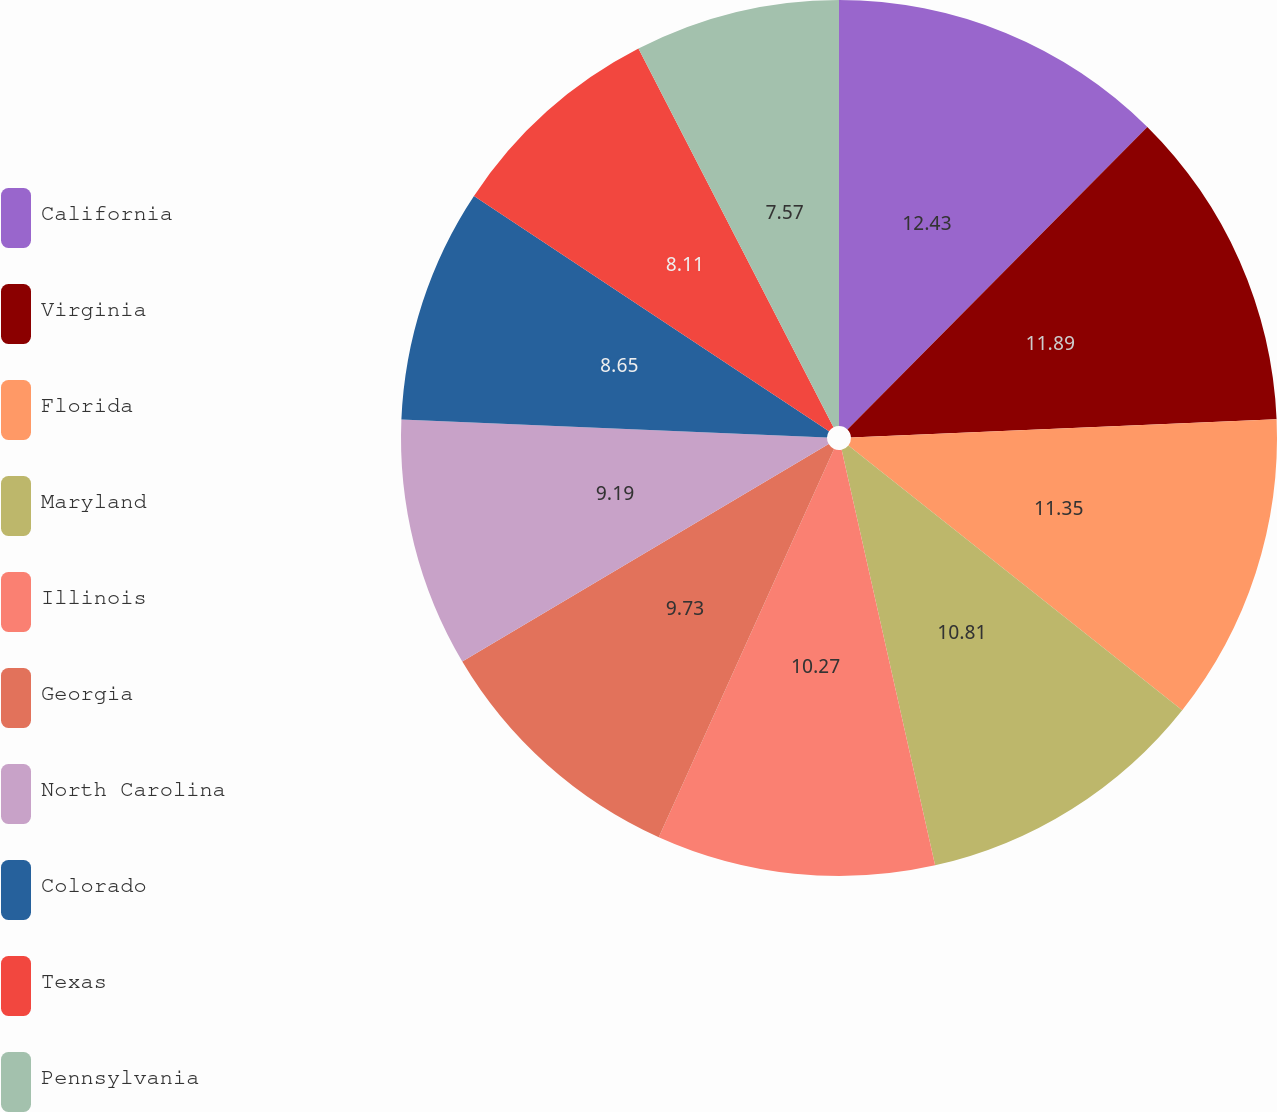Convert chart to OTSL. <chart><loc_0><loc_0><loc_500><loc_500><pie_chart><fcel>California<fcel>Virginia<fcel>Florida<fcel>Maryland<fcel>Illinois<fcel>Georgia<fcel>North Carolina<fcel>Colorado<fcel>Texas<fcel>Pennsylvania<nl><fcel>12.43%<fcel>11.89%<fcel>11.35%<fcel>10.81%<fcel>10.27%<fcel>9.73%<fcel>9.19%<fcel>8.65%<fcel>8.11%<fcel>7.57%<nl></chart> 